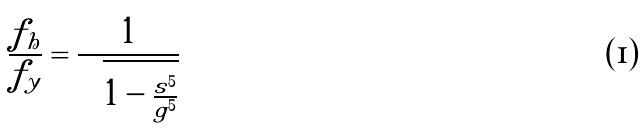Convert formula to latex. <formula><loc_0><loc_0><loc_500><loc_500>\frac { f _ { h } } { f _ { y } } = \frac { 1 } { \sqrt { 1 - \frac { s ^ { 5 } } { g ^ { 5 } } } }</formula> 